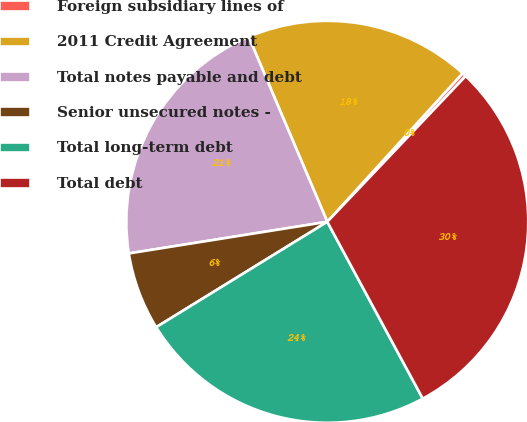Convert chart. <chart><loc_0><loc_0><loc_500><loc_500><pie_chart><fcel>Foreign subsidiary lines of<fcel>2011 Credit Agreement<fcel>Total notes payable and debt<fcel>Senior unsecured notes -<fcel>Total long-term debt<fcel>Total debt<nl><fcel>0.33%<fcel>18.15%<fcel>21.12%<fcel>6.27%<fcel>24.09%<fcel>30.03%<nl></chart> 